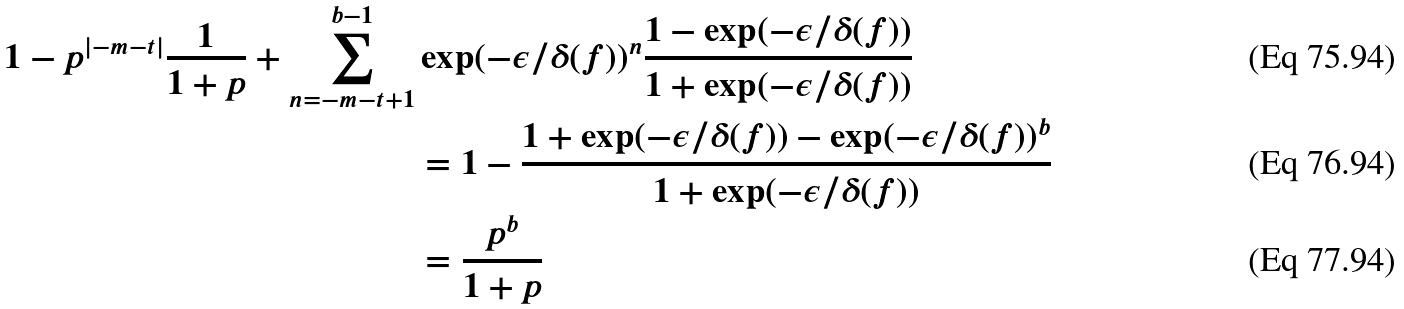Convert formula to latex. <formula><loc_0><loc_0><loc_500><loc_500>1 - p ^ { | - m - t | } \frac { 1 } { 1 + p } + \sum _ { n = - m - t + 1 } ^ { b - 1 } & \exp ( - \epsilon / \delta ( f ) ) ^ { n } \frac { 1 - \exp ( - \epsilon / \delta ( f ) ) } { 1 + \exp ( - \epsilon / \delta ( f ) ) } \\ & = 1 - \frac { 1 + \exp ( - \epsilon / \delta ( f ) ) - \exp ( - \epsilon / \delta ( f ) ) ^ { b } } { 1 + \exp ( - \epsilon / \delta ( f ) ) } \\ & = \frac { p ^ { b } } { 1 + p }</formula> 